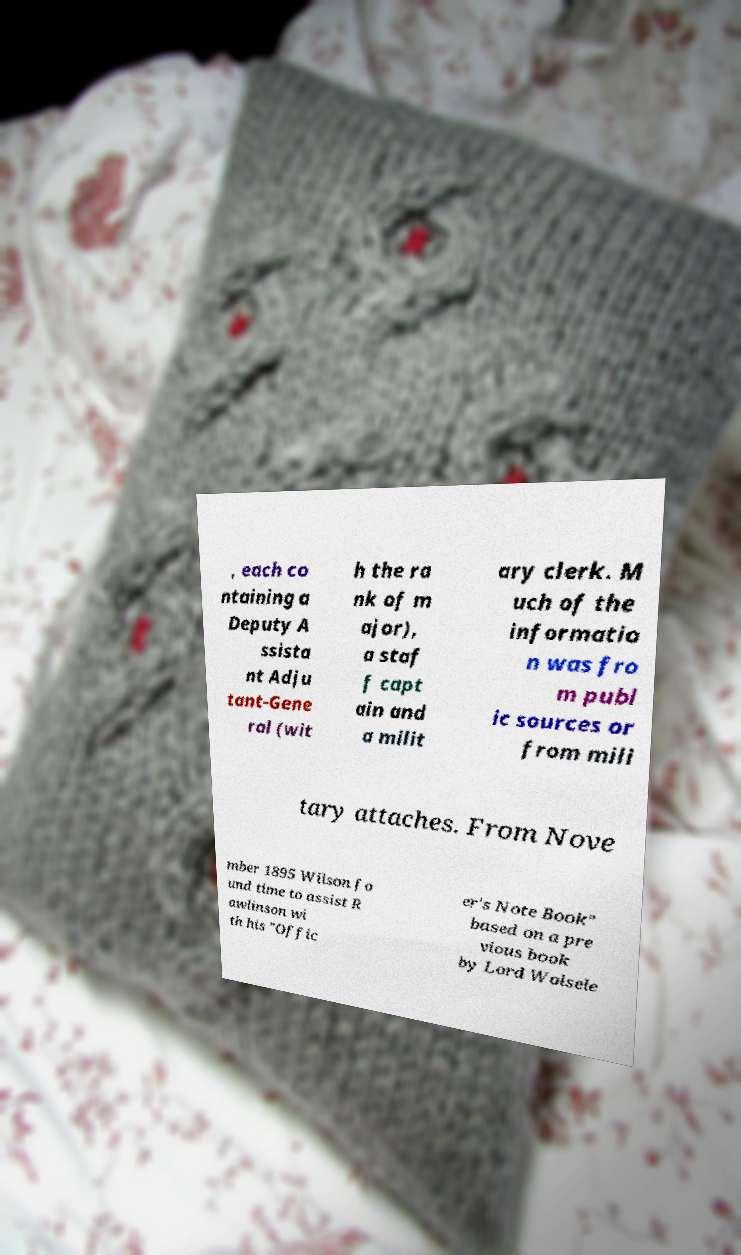Please read and relay the text visible in this image. What does it say? , each co ntaining a Deputy A ssista nt Adju tant-Gene ral (wit h the ra nk of m ajor), a staf f capt ain and a milit ary clerk. M uch of the informatio n was fro m publ ic sources or from mili tary attaches. From Nove mber 1895 Wilson fo und time to assist R awlinson wi th his "Offic er's Note Book" based on a pre vious book by Lord Wolsele 